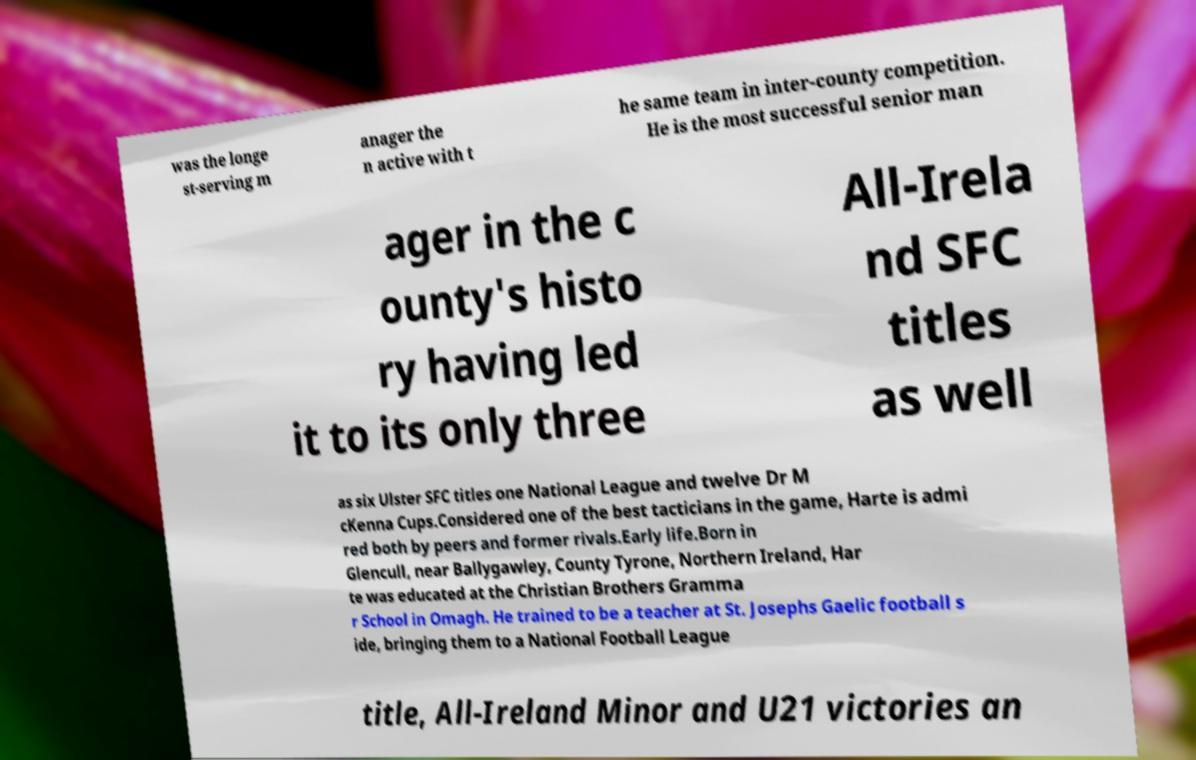What messages or text are displayed in this image? I need them in a readable, typed format. was the longe st-serving m anager the n active with t he same team in inter-county competition. He is the most successful senior man ager in the c ounty's histo ry having led it to its only three All-Irela nd SFC titles as well as six Ulster SFC titles one National League and twelve Dr M cKenna Cups.Considered one of the best tacticians in the game, Harte is admi red both by peers and former rivals.Early life.Born in Glencull, near Ballygawley, County Tyrone, Northern Ireland, Har te was educated at the Christian Brothers Gramma r School in Omagh. He trained to be a teacher at St. Josephs Gaelic football s ide, bringing them to a National Football League title, All-Ireland Minor and U21 victories an 